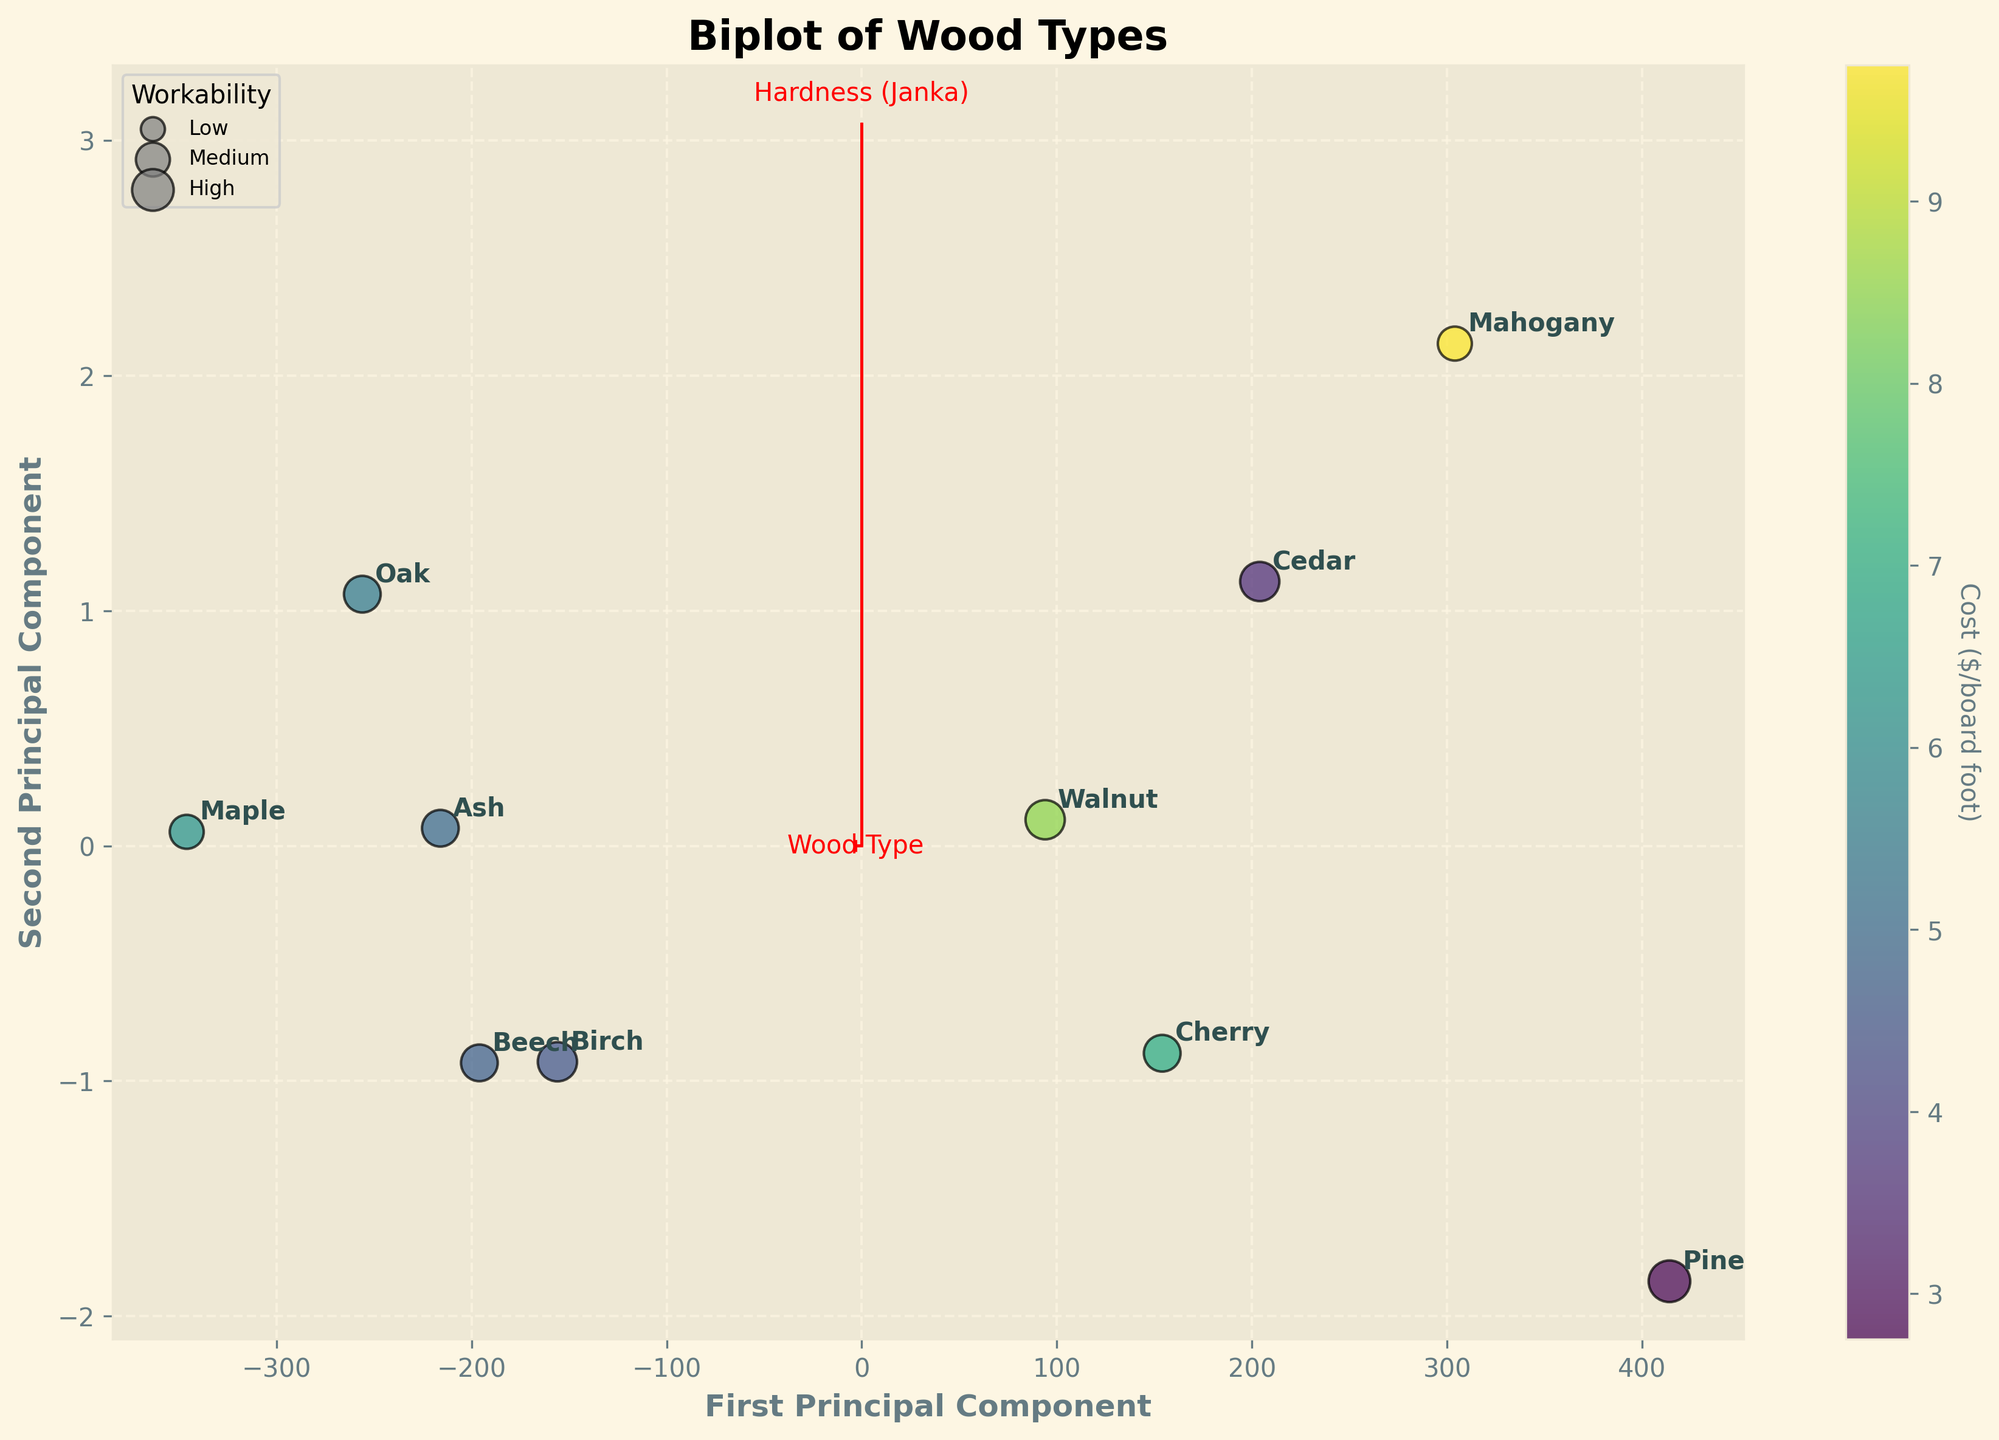How many wood types are analyzed in this biplot? Count each unique label displayed in the plot that indicates a wood type.
Answer: 10 How is 'Cost ($/board foot)' represented in the biplot? Color represents 'Cost ($/board foot)', with different colors indicating varying cost levels.
Answer: Color Which wood type is positioned closest to the origin in the biplot? Identify the data point that appears nearest to the center of the plot (origin).
Answer: Oak Which wood type has the highest workability? Compare the size of the data points since workability is represented by the size of the points. The largest point indicates the highest workability.
Answer: Pine Is there a visible correlation between hardness and durability in the biplot? Look at the direction and spread of data points on the plot. If the points are roughly aligned in a specific direction, it suggests a correlation.
Answer: Yes Which wood type appears furthest from the origin along the first principal component? Find the point that is the farthest along the horizontal axis of the biplot.
Answer: Maple Which wood type has the lowest cost and how does it compare in workability? Look for the data point with the color representing the lowest cost ($2.75/board foot) and compare its size to others. Pine has the lowest cost and a high workability indicated by a large point size.
Answer: Pine How does Cedar's durability compare to Mahogany's? Locate both Cedar and Mahogany in the plot and compare their positions relative to the durability axis. Cedar is positioned higher on the durability axis than Mahogany.
Answer: Cedar is more durable Do any of the wood types stand out as having high suitability for children? Identify points where the annotation labels match the higher end of the suitability scale for children and see if they cluster favorably within the axes. Pine and Cedar are among the wood types with high suitability for children.
Answer: Pine, Cedar Among the wood types with similar hardness, which one has the highest cost? Compare the hardness positions of various points and then look at their corresponding colors representing cost. Maple, positioned close to Oak and Ash in hardness, has a higher cost judging by the color.
Answer: Maple 